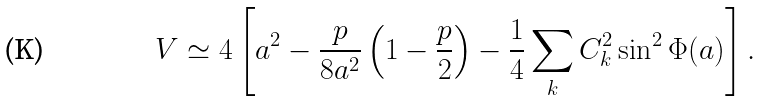Convert formula to latex. <formula><loc_0><loc_0><loc_500><loc_500>V \simeq 4 \left [ a ^ { 2 } - \frac { p } { 8 a ^ { 2 } } \left ( 1 - \frac { p } { 2 } \right ) - \frac { 1 } { 4 } \sum _ { k } C _ { k } ^ { 2 } \sin ^ { 2 } \Phi ( a ) \right ] .</formula> 